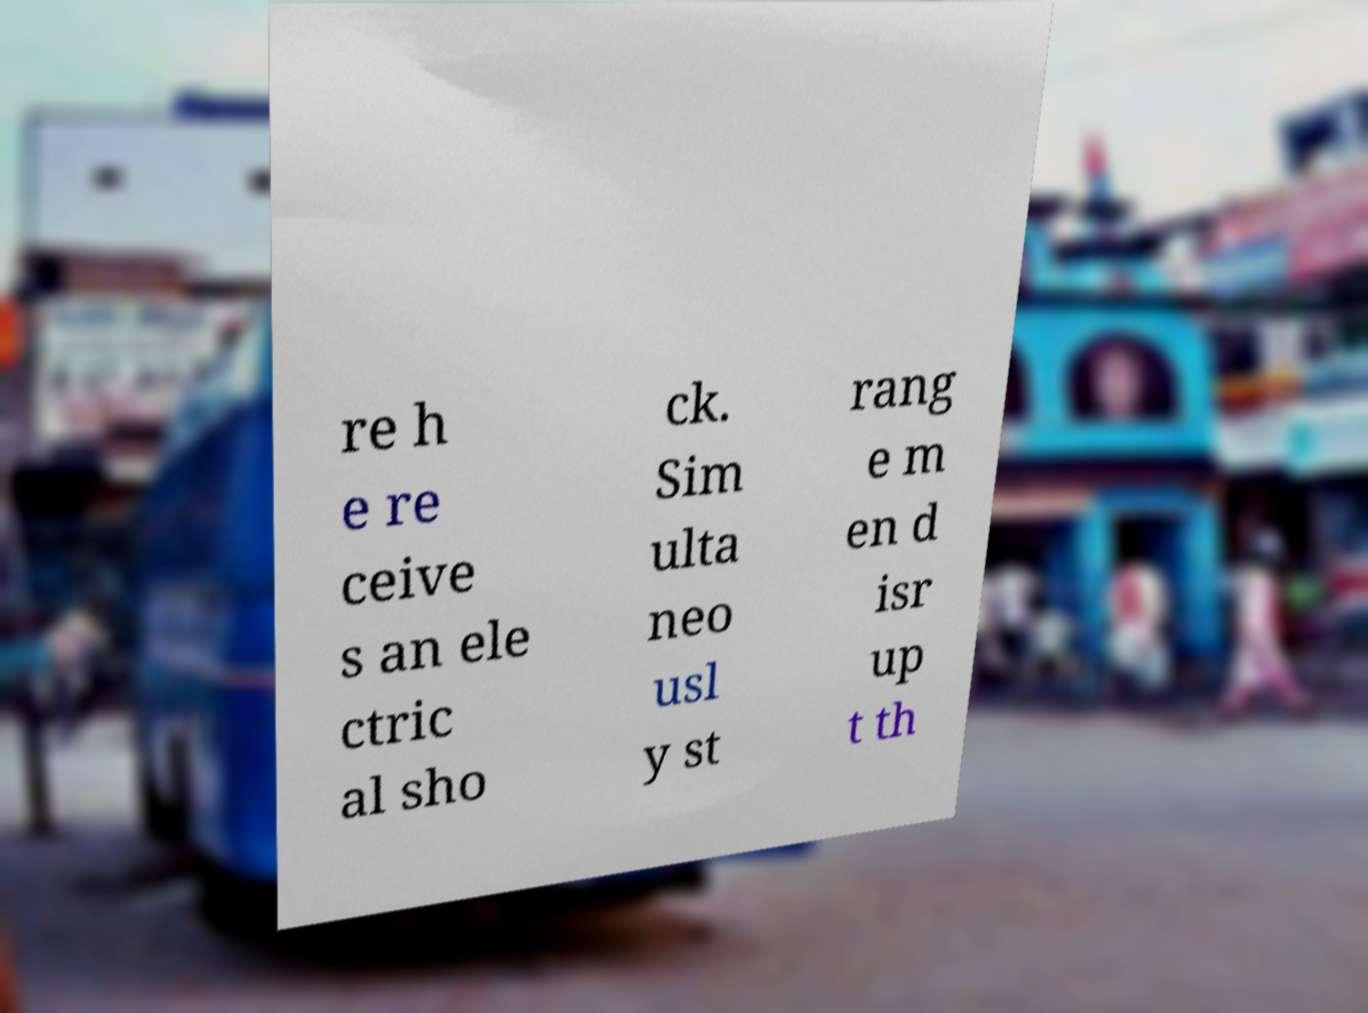Please read and relay the text visible in this image. What does it say? re h e re ceive s an ele ctric al sho ck. Sim ulta neo usl y st rang e m en d isr up t th 